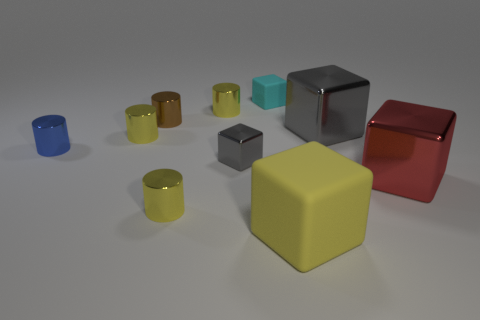There is a thing that is the same color as the tiny shiny block; what is its size?
Make the answer very short. Large. Is there another tiny metal thing of the same shape as the small blue thing?
Your response must be concise. Yes. What number of objects are either large blue cylinders or tiny gray metallic blocks?
Provide a short and direct response. 1. There is a rubber block in front of the cyan rubber block that is right of the small blue cylinder; what number of small brown cylinders are on the left side of it?
Offer a terse response. 1. There is a tiny cyan object that is the same shape as the large rubber thing; what is it made of?
Ensure brevity in your answer.  Rubber. What is the material of the yellow object that is both on the left side of the tiny cyan block and in front of the blue shiny thing?
Make the answer very short. Metal. Is the number of small yellow cylinders in front of the tiny brown cylinder less than the number of small shiny cylinders behind the small blue metallic cylinder?
Keep it short and to the point. Yes. How many other objects are there of the same size as the brown object?
Provide a short and direct response. 6. What shape is the gray thing to the right of the tiny thing behind the tiny metal cylinder that is behind the brown cylinder?
Provide a short and direct response. Cube. What number of red things are either rubber things or big cubes?
Provide a succinct answer. 1. 